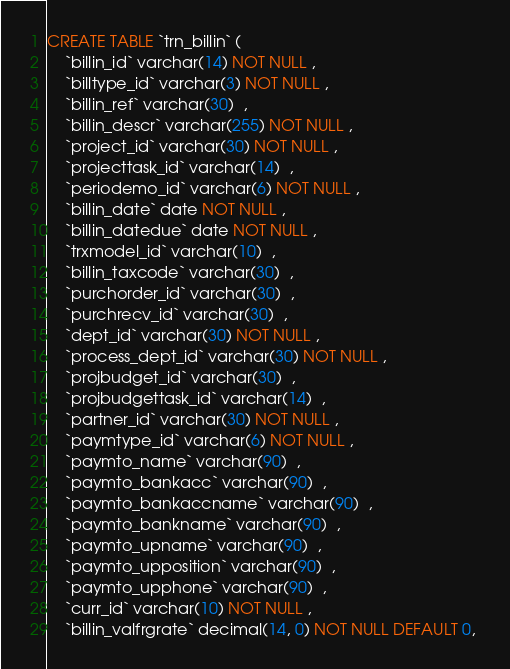Convert code to text. <code><loc_0><loc_0><loc_500><loc_500><_SQL_>CREATE TABLE `trn_billin` (
	`billin_id` varchar(14) NOT NULL , 
	`billtype_id` varchar(3) NOT NULL , 
	`billin_ref` varchar(30)  , 
	`billin_descr` varchar(255) NOT NULL , 
	`project_id` varchar(30) NOT NULL , 
	`projecttask_id` varchar(14)  , 
	`periodemo_id` varchar(6) NOT NULL , 
	`billin_date` date NOT NULL , 
	`billin_datedue` date NOT NULL , 
	`trxmodel_id` varchar(10)  , 
	`billin_taxcode` varchar(30)  , 
	`purchorder_id` varchar(30)  , 
	`purchrecv_id` varchar(30)  , 
	`dept_id` varchar(30) NOT NULL , 
	`process_dept_id` varchar(30) NOT NULL , 
	`projbudget_id` varchar(30)  , 
	`projbudgettask_id` varchar(14)  , 
	`partner_id` varchar(30) NOT NULL , 
	`paymtype_id` varchar(6) NOT NULL , 
	`paymto_name` varchar(90)  , 
	`paymto_bankacc` varchar(90)  , 
	`paymto_bankaccname` varchar(90)  , 
	`paymto_bankname` varchar(90)  , 
	`paymto_upname` varchar(90)  , 
	`paymto_upposition` varchar(90)  , 
	`paymto_upphone` varchar(90)  , 
	`curr_id` varchar(10) NOT NULL , 
	`billin_valfrgrate` decimal(14, 0) NOT NULL DEFAULT 0, </code> 